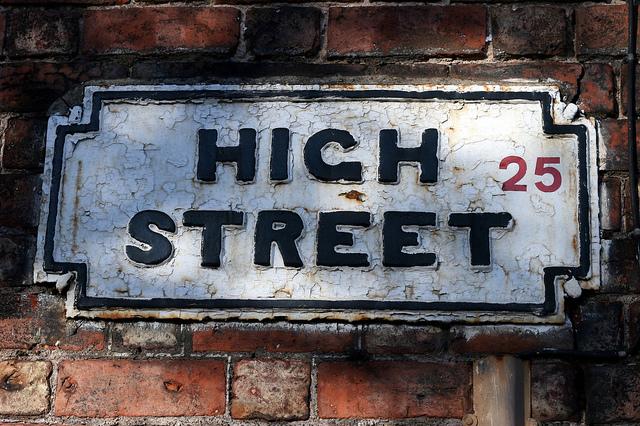What does it say on the street sign?
Answer briefly. High street. Is the wall new?
Be succinct. No. What material is the wall constructed of?
Keep it brief. Brick. 